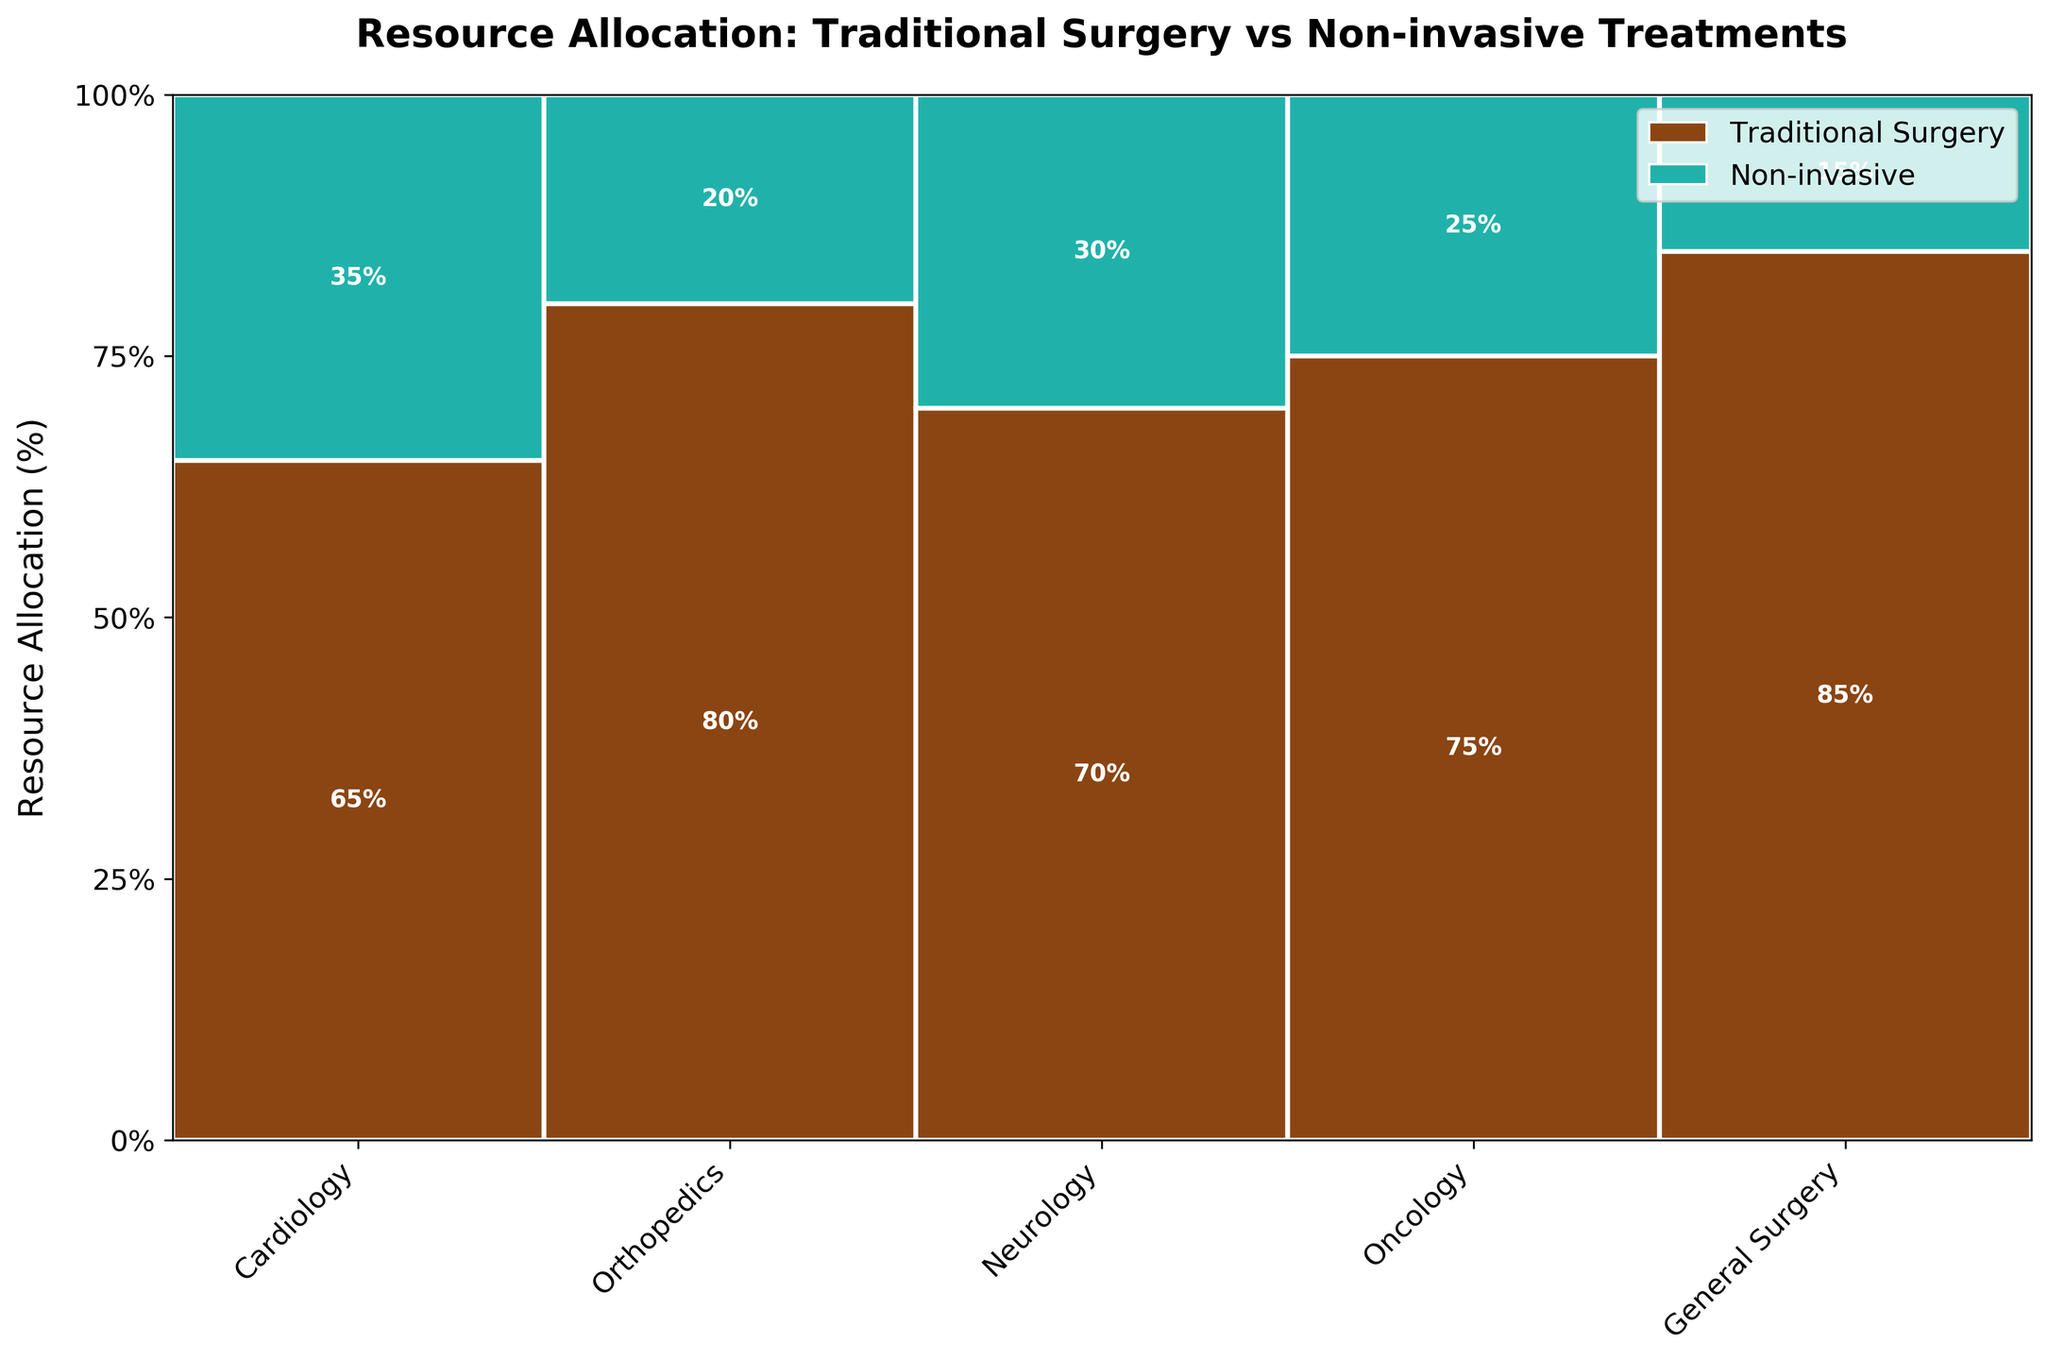Which department has the highest allocation for traditional surgeries? General Surgery has an allocation of 85% for traditional surgeries, which is the highest among all departments as compared to others such as Cardiology (65%), Orthopedics (80%), Neurology (70%), and Oncology (75%).
Answer: General Surgery How many departments allocate more than 70% of their resources to traditional surgeries? Examine the bars for each department. Both General Surgery (85%), Orthopedics (80%), Neurology (70%), and Oncology (75%) allocate more than 70% to traditional surgeries. Therefore, 4 departments allocate more than 70% to traditional surgeries.
Answer: 4 Which treatment receives more resources overall in the Cardiology department? In the Cardiology section, the traditional surgeries bar is taller compared to the non-invasive treatments bar, with allocations of 65% and 35% respectively.
Answer: Traditional Surgery What is the total percentage of resources allocated to non-invasive treatments across all departments? Sum the resource allocations for non-invasive treatments in all departments: Cardiology (35%) + Orthopedics (20%) + Neurology (30%) + Oncology (25%) + General Surgery (15%) = 125%.
Answer: 125% Which department has the smallest allocation for non-invasive treatments? Inspecting the allocated percentages, General Surgery has the smallest allocation for non-invasive treatments at 15%, compared to Cardiology (35%), Orthopedics (20%), Neurology (30%), and Oncology (25%).
Answer: General Surgery Compare the resource allocation for traditional surgeries between Neurology and Oncology. Which has more, and by how much? Neurology has an allocation of 70% for traditional surgeries, while Oncology has 75%. The difference is calculated as 75% - 70% = 5%. Therefore, Oncology allocates 5% more resources to traditional surgeries than Neurology.
Answer: Oncology by 5% What is the average resource allocation to traditional surgeries across all departments? Sum the individual resource allocations for traditional surgeries and then divide by the number of departments: (65% + 80% + 70% + 75% + 85%) / 5 = 75%. Thus, the average allocation is 75%.
Answer: 75% Which department is allocated the majority of its resources to non-invasive treatments? Cardiology has the highest allocation to non-invasive treatments at 35%, which is more than any other department.
Answer: Cardiology 